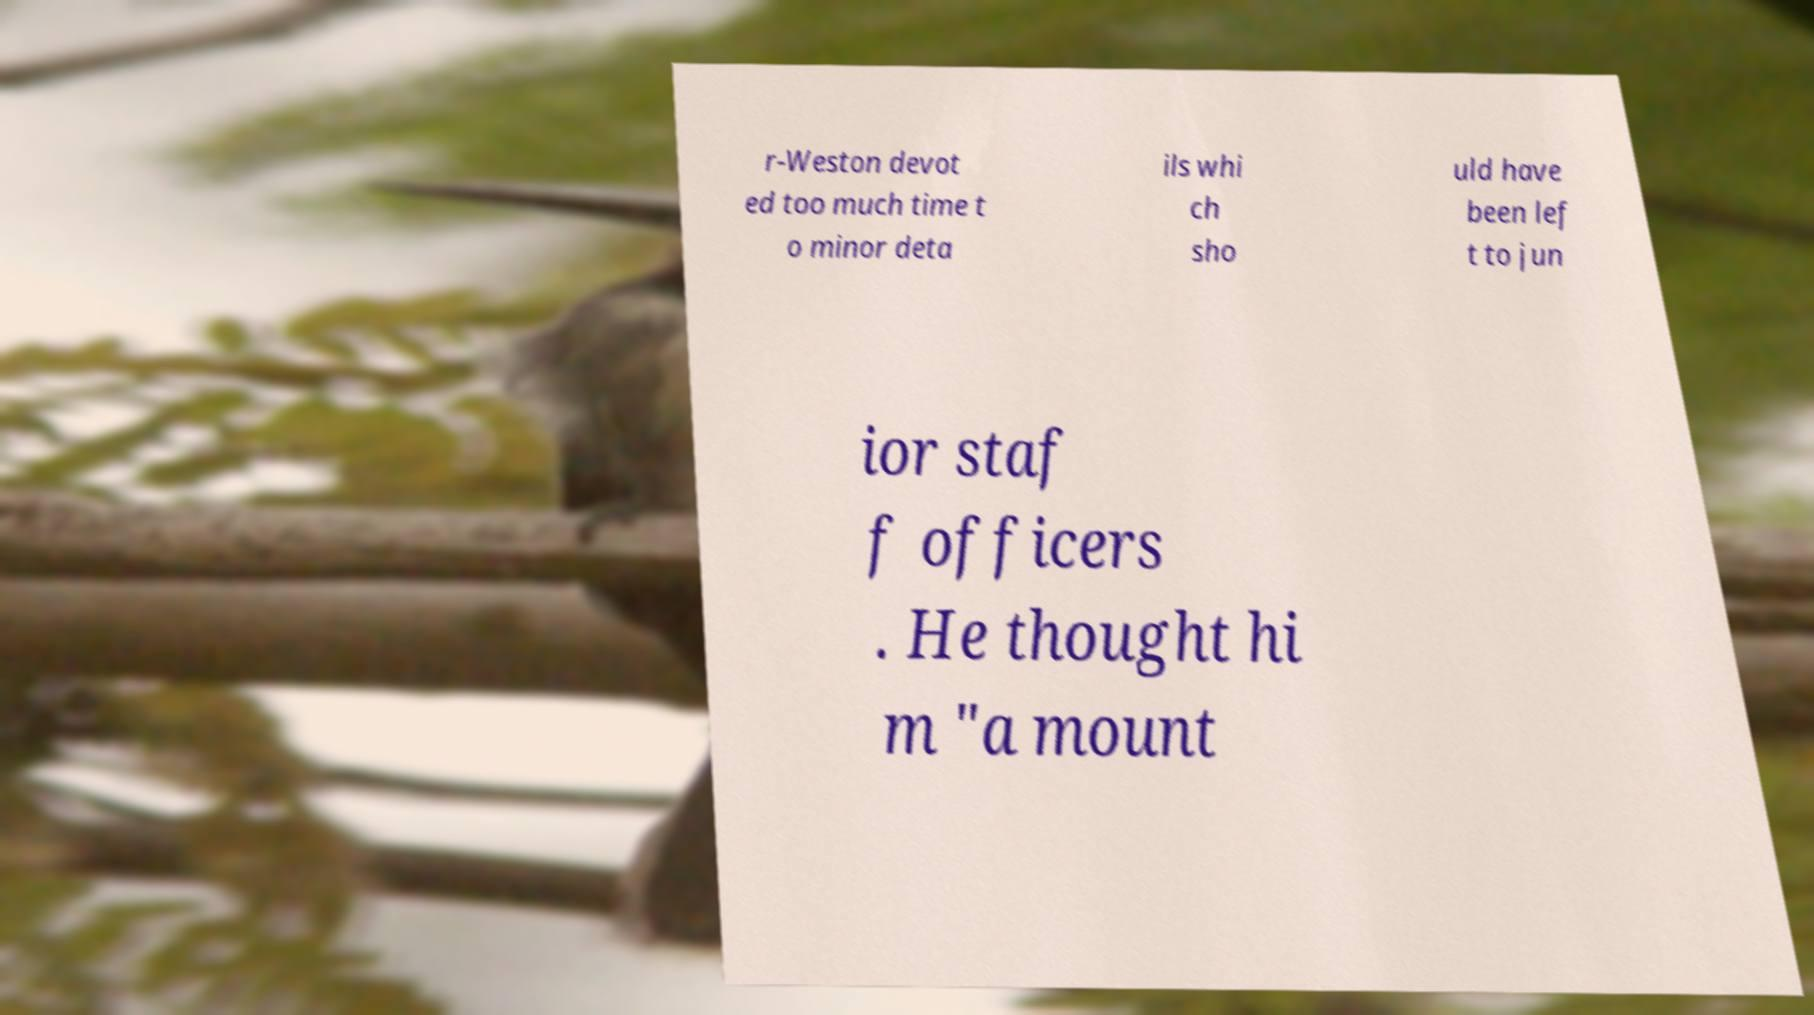Please identify and transcribe the text found in this image. r-Weston devot ed too much time t o minor deta ils whi ch sho uld have been lef t to jun ior staf f officers . He thought hi m "a mount 